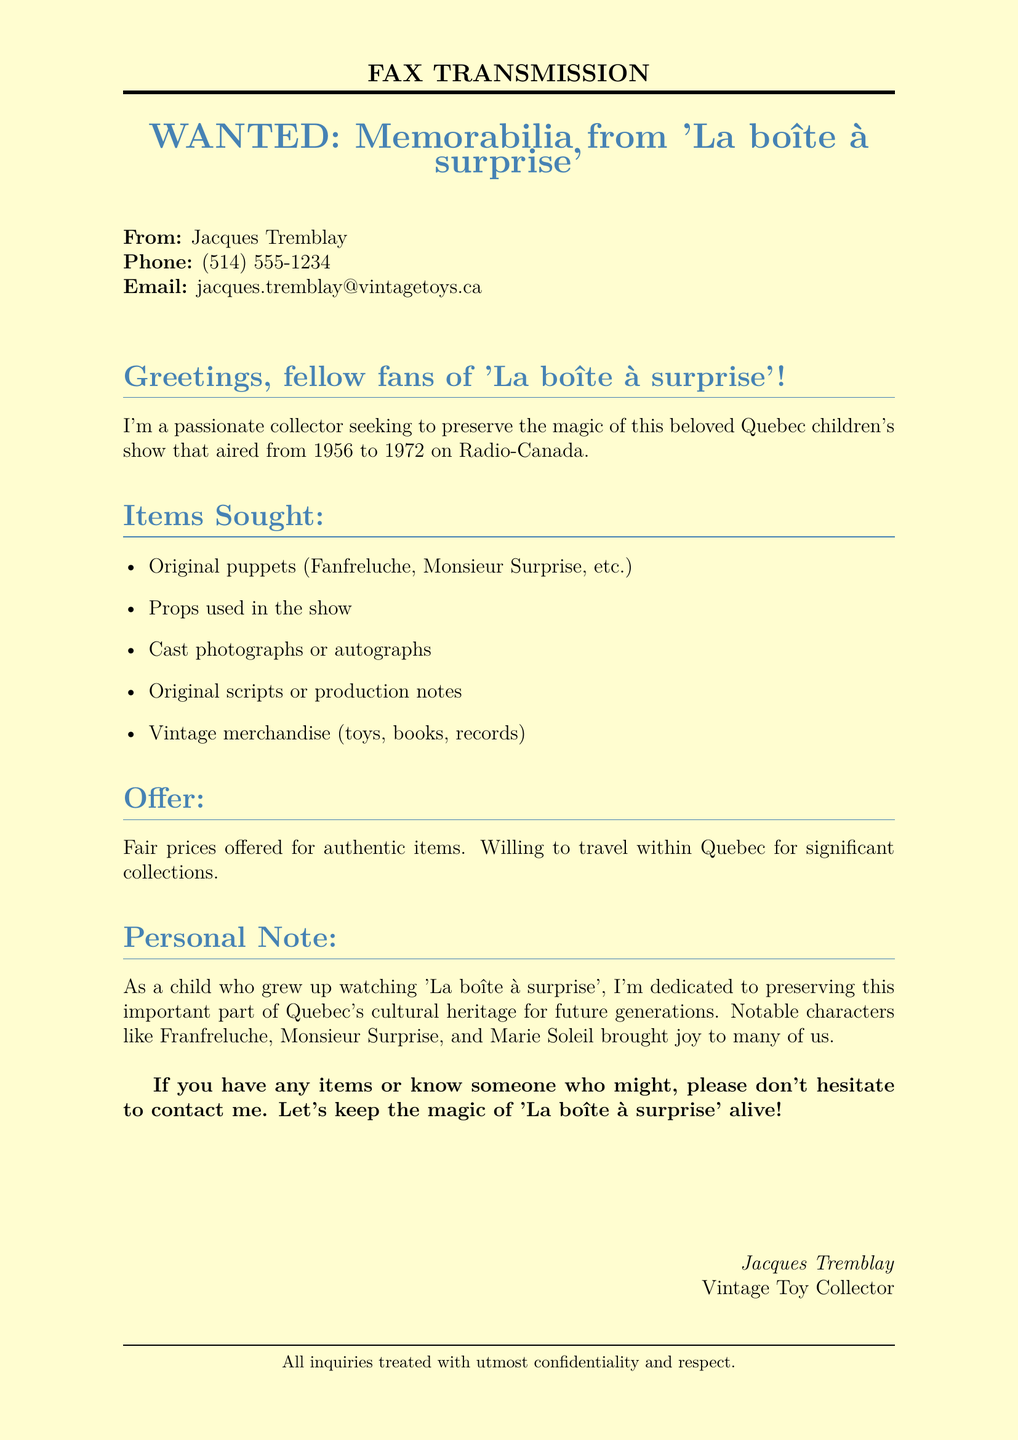What is the name of the collector? The fax states that the collector's name is Jacques Tremblay.
Answer: Jacques Tremblay What items are being sought? The document lists specific items the collector is looking for, including original puppets, props, and more.
Answer: Original puppets, props, cast photographs, original scripts, vintage merchandise What year did 'La boîte à surprise' first air? The document mentions the starting year of the show as 1956.
Answer: 1956 What is the collector's phone number? The fax provides Jacques Tremblay's contact number.
Answer: (514) 555-1234 What type of items will fair prices be offered for? The document specifies that fair prices will be offered for authentic items.
Answer: Authentic items What is the purpose of Jacques Tremblay seeking memorabilia? It states that the purpose is to preserve the magic of the show for future generations.
Answer: Preserve the magic How long did 'La boîte à surprise' run? The document indicates that the show aired until 1972, thus running for 16 years.
Answer: 16 years What is the email address provided for contact? The fax lists Jacques Tremblay's email for potential contacts.
Answer: jacques.tremblay@vintagetoys.ca Is the collector willing to travel? The document mentions that the collector is willing to travel within Quebec for significant collections.
Answer: Yes 